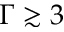<formula> <loc_0><loc_0><loc_500><loc_500>\Gamma \gtrsim 3</formula> 